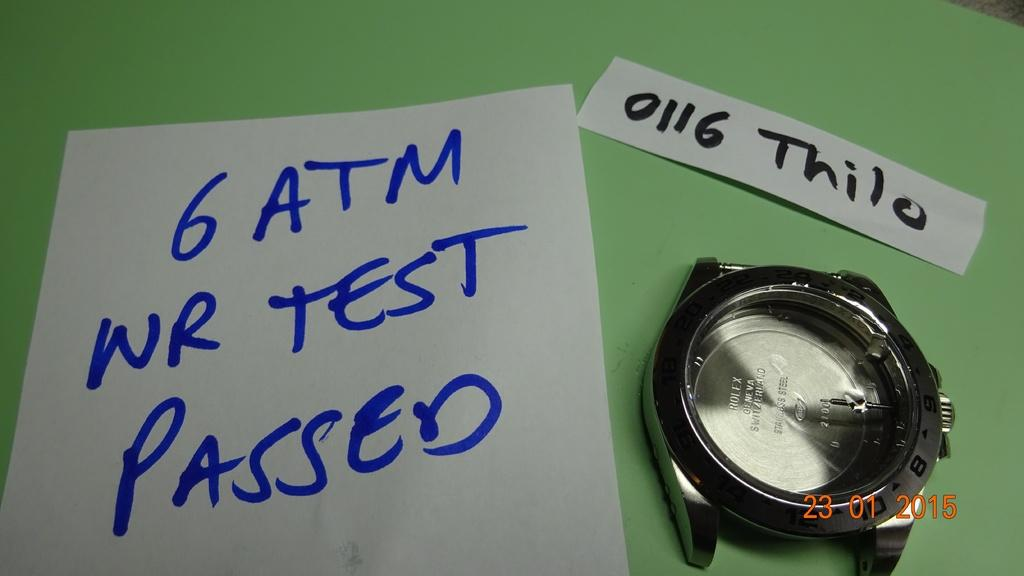<image>
Give a short and clear explanation of the subsequent image. "6 ATM WR TEST PASSED" is on a piece of paper next to a watch. 